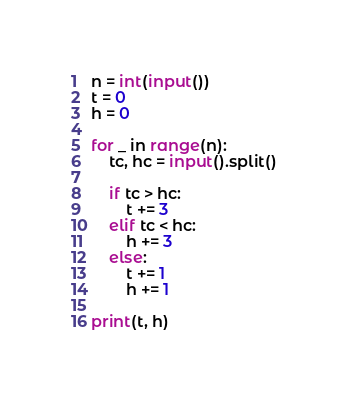Convert code to text. <code><loc_0><loc_0><loc_500><loc_500><_Python_>n = int(input())
t = 0
h = 0

for _ in range(n):
    tc, hc = input().split()

    if tc > hc:
        t += 3
    elif tc < hc:
        h += 3
    else:
        t += 1
        h += 1

print(t, h)
</code> 